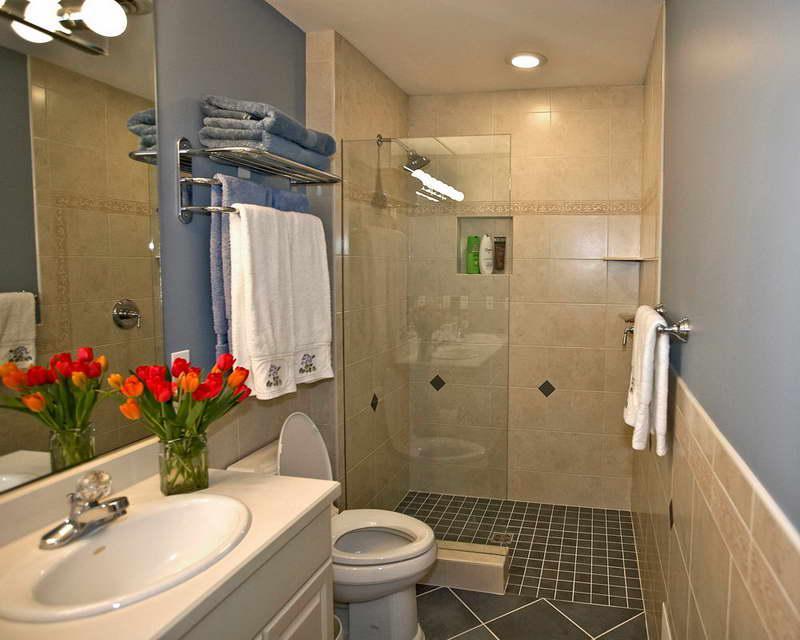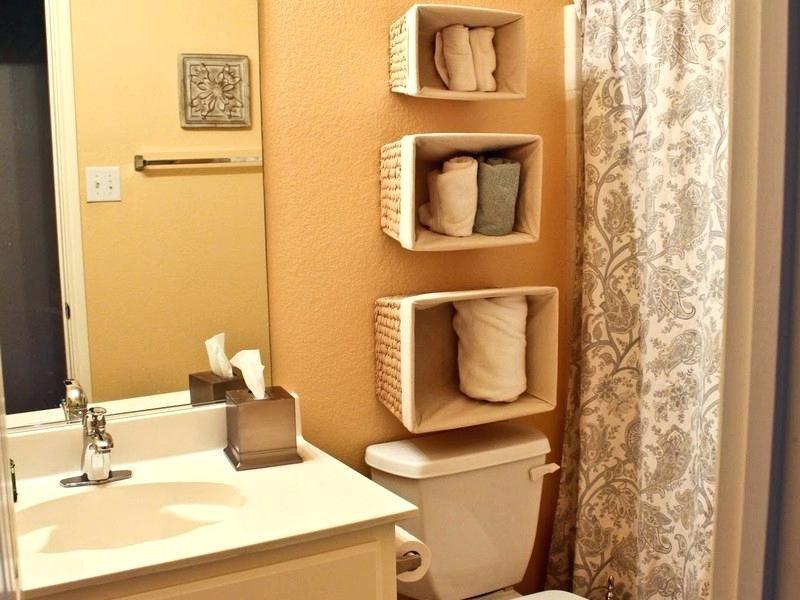The first image is the image on the left, the second image is the image on the right. For the images displayed, is the sentence "In the image to the right, there are flowers on the bathroom counter." factually correct? Answer yes or no. No. The first image is the image on the left, the second image is the image on the right. Examine the images to the left and right. Is the description "There is no more than three towels." accurate? Answer yes or no. No. 